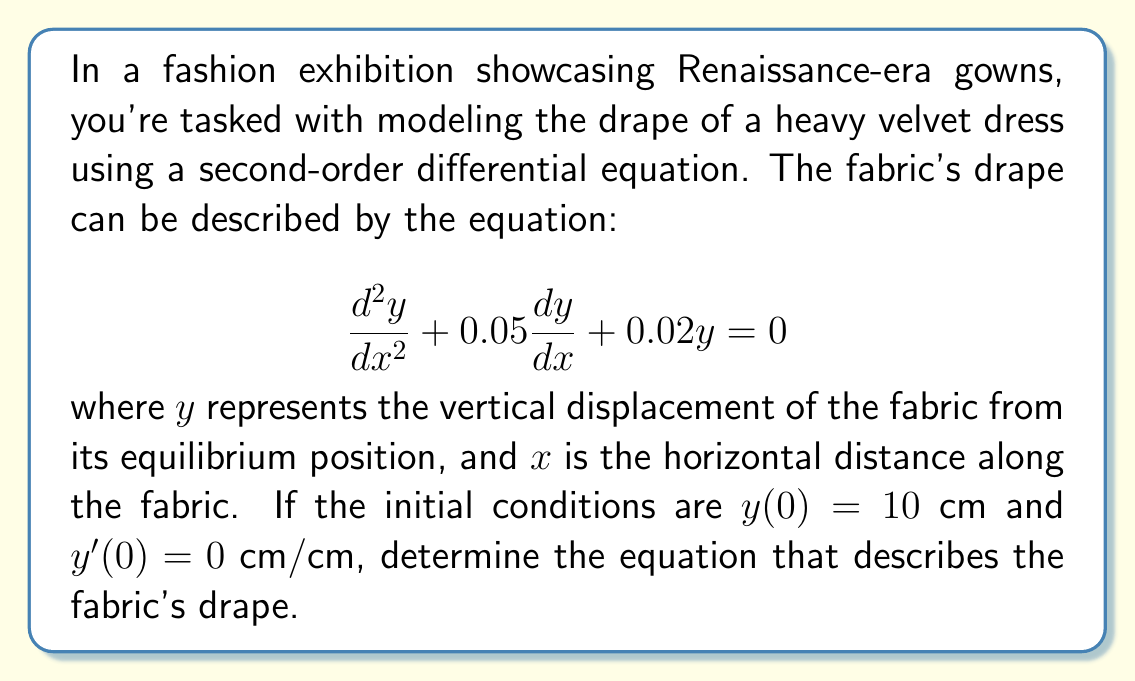Teach me how to tackle this problem. To solve this second-order linear differential equation, we'll follow these steps:

1) First, we need to find the characteristic equation. For a second-order equation of the form:

   $$a\frac{d^2y}{dx^2} + b\frac{dy}{dx} + cy = 0$$

   The characteristic equation is $ar^2 + br + c = 0$.

2) In our case, $a=1$, $b=0.05$, and $c=0.02$. So our characteristic equation is:

   $$r^2 + 0.05r + 0.02 = 0$$

3) We can solve this using the quadratic formula: $r = \frac{-b \pm \sqrt{b^2 - 4ac}}{2a}$

   $$r = \frac{-0.05 \pm \sqrt{0.05^2 - 4(1)(0.02)}}{2(1)}$$
   $$r = \frac{-0.05 \pm \sqrt{0.0025 - 0.08}}{2}$$
   $$r = \frac{-0.05 \pm \sqrt{-0.0775}}{2}$$

4) This gives us complex roots:

   $$r_1 = -0.025 + 0.139i$$
   $$r_2 = -0.025 - 0.139i$$

5) The general solution for complex roots is:

   $$y = e^{\alpha x}(A\cos(\beta x) + B\sin(\beta x))$$

   where $\alpha$ is the real part and $\beta$ is the imaginary part of the roots.

6) Substituting our values:

   $$y = e^{-0.025x}(A\cos(0.139x) + B\sin(0.139x))$$

7) Now we use the initial conditions to find $A$ and $B$:

   $y(0) = 10$ gives us $A = 10$

   $y'(0) = 0$ gives us $-0.025A + 0.139B = 0$, so $B = 1.799$

8) Our final solution is:

   $$y = e^{-0.025x}(10\cos(0.139x) + 1.799\sin(0.139x))$$

This equation describes the drape of the fabric.
Answer: $$y = e^{-0.025x}(10\cos(0.139x) + 1.799\sin(0.139x))$$ 